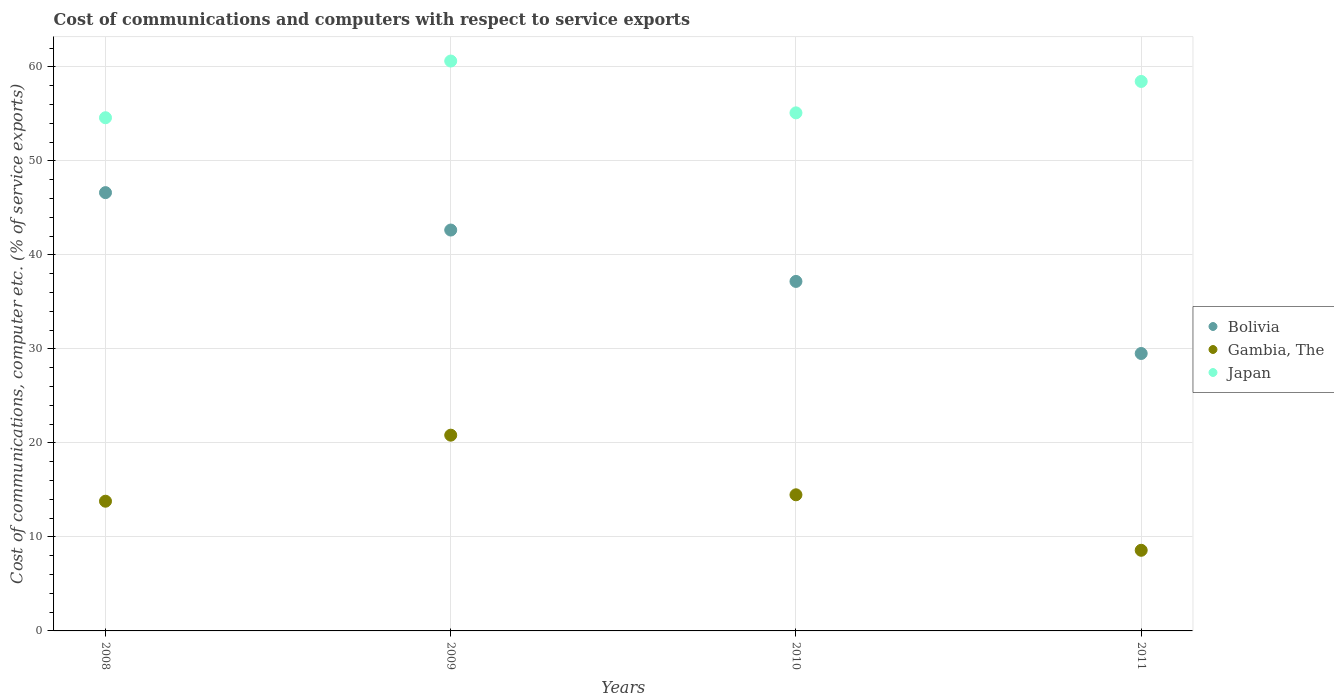How many different coloured dotlines are there?
Make the answer very short. 3. Is the number of dotlines equal to the number of legend labels?
Offer a terse response. Yes. What is the cost of communications and computers in Japan in 2010?
Offer a very short reply. 55.12. Across all years, what is the maximum cost of communications and computers in Japan?
Your answer should be very brief. 60.63. Across all years, what is the minimum cost of communications and computers in Japan?
Offer a very short reply. 54.6. In which year was the cost of communications and computers in Bolivia minimum?
Give a very brief answer. 2011. What is the total cost of communications and computers in Gambia, The in the graph?
Your response must be concise. 57.68. What is the difference between the cost of communications and computers in Gambia, The in 2010 and that in 2011?
Provide a short and direct response. 5.9. What is the difference between the cost of communications and computers in Gambia, The in 2011 and the cost of communications and computers in Bolivia in 2009?
Your response must be concise. -34.07. What is the average cost of communications and computers in Gambia, The per year?
Your answer should be compact. 14.42. In the year 2010, what is the difference between the cost of communications and computers in Japan and cost of communications and computers in Bolivia?
Keep it short and to the point. 17.93. What is the ratio of the cost of communications and computers in Gambia, The in 2009 to that in 2011?
Your answer should be very brief. 2.43. Is the cost of communications and computers in Japan in 2008 less than that in 2009?
Keep it short and to the point. Yes. Is the difference between the cost of communications and computers in Japan in 2008 and 2009 greater than the difference between the cost of communications and computers in Bolivia in 2008 and 2009?
Make the answer very short. No. What is the difference between the highest and the second highest cost of communications and computers in Japan?
Offer a terse response. 2.17. What is the difference between the highest and the lowest cost of communications and computers in Gambia, The?
Your answer should be very brief. 12.25. Is the sum of the cost of communications and computers in Gambia, The in 2009 and 2010 greater than the maximum cost of communications and computers in Bolivia across all years?
Provide a short and direct response. No. Does the graph contain any zero values?
Provide a short and direct response. No. Does the graph contain grids?
Offer a very short reply. Yes. Where does the legend appear in the graph?
Your answer should be compact. Center right. What is the title of the graph?
Keep it short and to the point. Cost of communications and computers with respect to service exports. Does "Upper middle income" appear as one of the legend labels in the graph?
Your answer should be very brief. No. What is the label or title of the X-axis?
Ensure brevity in your answer.  Years. What is the label or title of the Y-axis?
Provide a succinct answer. Cost of communications, computer etc. (% of service exports). What is the Cost of communications, computer etc. (% of service exports) in Bolivia in 2008?
Make the answer very short. 46.63. What is the Cost of communications, computer etc. (% of service exports) in Gambia, The in 2008?
Offer a very short reply. 13.8. What is the Cost of communications, computer etc. (% of service exports) in Japan in 2008?
Give a very brief answer. 54.6. What is the Cost of communications, computer etc. (% of service exports) in Bolivia in 2009?
Offer a very short reply. 42.65. What is the Cost of communications, computer etc. (% of service exports) in Gambia, The in 2009?
Your answer should be very brief. 20.83. What is the Cost of communications, computer etc. (% of service exports) of Japan in 2009?
Offer a very short reply. 60.63. What is the Cost of communications, computer etc. (% of service exports) of Bolivia in 2010?
Make the answer very short. 37.18. What is the Cost of communications, computer etc. (% of service exports) of Gambia, The in 2010?
Your response must be concise. 14.48. What is the Cost of communications, computer etc. (% of service exports) of Japan in 2010?
Make the answer very short. 55.12. What is the Cost of communications, computer etc. (% of service exports) in Bolivia in 2011?
Provide a short and direct response. 29.52. What is the Cost of communications, computer etc. (% of service exports) of Gambia, The in 2011?
Your answer should be very brief. 8.58. What is the Cost of communications, computer etc. (% of service exports) of Japan in 2011?
Ensure brevity in your answer.  58.46. Across all years, what is the maximum Cost of communications, computer etc. (% of service exports) of Bolivia?
Offer a terse response. 46.63. Across all years, what is the maximum Cost of communications, computer etc. (% of service exports) in Gambia, The?
Give a very brief answer. 20.83. Across all years, what is the maximum Cost of communications, computer etc. (% of service exports) of Japan?
Offer a terse response. 60.63. Across all years, what is the minimum Cost of communications, computer etc. (% of service exports) of Bolivia?
Your answer should be compact. 29.52. Across all years, what is the minimum Cost of communications, computer etc. (% of service exports) of Gambia, The?
Your answer should be compact. 8.58. Across all years, what is the minimum Cost of communications, computer etc. (% of service exports) of Japan?
Your response must be concise. 54.6. What is the total Cost of communications, computer etc. (% of service exports) in Bolivia in the graph?
Your response must be concise. 155.98. What is the total Cost of communications, computer etc. (% of service exports) in Gambia, The in the graph?
Make the answer very short. 57.68. What is the total Cost of communications, computer etc. (% of service exports) in Japan in the graph?
Provide a short and direct response. 228.8. What is the difference between the Cost of communications, computer etc. (% of service exports) of Bolivia in 2008 and that in 2009?
Give a very brief answer. 3.98. What is the difference between the Cost of communications, computer etc. (% of service exports) of Gambia, The in 2008 and that in 2009?
Give a very brief answer. -7.03. What is the difference between the Cost of communications, computer etc. (% of service exports) of Japan in 2008 and that in 2009?
Provide a short and direct response. -6.03. What is the difference between the Cost of communications, computer etc. (% of service exports) of Bolivia in 2008 and that in 2010?
Your answer should be compact. 9.45. What is the difference between the Cost of communications, computer etc. (% of service exports) in Gambia, The in 2008 and that in 2010?
Make the answer very short. -0.68. What is the difference between the Cost of communications, computer etc. (% of service exports) in Japan in 2008 and that in 2010?
Ensure brevity in your answer.  -0.52. What is the difference between the Cost of communications, computer etc. (% of service exports) of Bolivia in 2008 and that in 2011?
Your response must be concise. 17.11. What is the difference between the Cost of communications, computer etc. (% of service exports) in Gambia, The in 2008 and that in 2011?
Offer a terse response. 5.22. What is the difference between the Cost of communications, computer etc. (% of service exports) of Japan in 2008 and that in 2011?
Offer a terse response. -3.86. What is the difference between the Cost of communications, computer etc. (% of service exports) in Bolivia in 2009 and that in 2010?
Ensure brevity in your answer.  5.47. What is the difference between the Cost of communications, computer etc. (% of service exports) of Gambia, The in 2009 and that in 2010?
Provide a short and direct response. 6.34. What is the difference between the Cost of communications, computer etc. (% of service exports) of Japan in 2009 and that in 2010?
Your response must be concise. 5.51. What is the difference between the Cost of communications, computer etc. (% of service exports) in Bolivia in 2009 and that in 2011?
Give a very brief answer. 13.13. What is the difference between the Cost of communications, computer etc. (% of service exports) of Gambia, The in 2009 and that in 2011?
Offer a very short reply. 12.25. What is the difference between the Cost of communications, computer etc. (% of service exports) of Japan in 2009 and that in 2011?
Offer a very short reply. 2.17. What is the difference between the Cost of communications, computer etc. (% of service exports) in Bolivia in 2010 and that in 2011?
Your answer should be very brief. 7.67. What is the difference between the Cost of communications, computer etc. (% of service exports) in Gambia, The in 2010 and that in 2011?
Offer a terse response. 5.9. What is the difference between the Cost of communications, computer etc. (% of service exports) in Japan in 2010 and that in 2011?
Your answer should be compact. -3.34. What is the difference between the Cost of communications, computer etc. (% of service exports) in Bolivia in 2008 and the Cost of communications, computer etc. (% of service exports) in Gambia, The in 2009?
Make the answer very short. 25.8. What is the difference between the Cost of communications, computer etc. (% of service exports) of Bolivia in 2008 and the Cost of communications, computer etc. (% of service exports) of Japan in 2009?
Offer a very short reply. -14. What is the difference between the Cost of communications, computer etc. (% of service exports) in Gambia, The in 2008 and the Cost of communications, computer etc. (% of service exports) in Japan in 2009?
Ensure brevity in your answer.  -46.83. What is the difference between the Cost of communications, computer etc. (% of service exports) of Bolivia in 2008 and the Cost of communications, computer etc. (% of service exports) of Gambia, The in 2010?
Keep it short and to the point. 32.15. What is the difference between the Cost of communications, computer etc. (% of service exports) of Bolivia in 2008 and the Cost of communications, computer etc. (% of service exports) of Japan in 2010?
Your answer should be compact. -8.49. What is the difference between the Cost of communications, computer etc. (% of service exports) in Gambia, The in 2008 and the Cost of communications, computer etc. (% of service exports) in Japan in 2010?
Offer a very short reply. -41.32. What is the difference between the Cost of communications, computer etc. (% of service exports) in Bolivia in 2008 and the Cost of communications, computer etc. (% of service exports) in Gambia, The in 2011?
Your response must be concise. 38.05. What is the difference between the Cost of communications, computer etc. (% of service exports) of Bolivia in 2008 and the Cost of communications, computer etc. (% of service exports) of Japan in 2011?
Give a very brief answer. -11.83. What is the difference between the Cost of communications, computer etc. (% of service exports) of Gambia, The in 2008 and the Cost of communications, computer etc. (% of service exports) of Japan in 2011?
Provide a short and direct response. -44.66. What is the difference between the Cost of communications, computer etc. (% of service exports) of Bolivia in 2009 and the Cost of communications, computer etc. (% of service exports) of Gambia, The in 2010?
Make the answer very short. 28.17. What is the difference between the Cost of communications, computer etc. (% of service exports) in Bolivia in 2009 and the Cost of communications, computer etc. (% of service exports) in Japan in 2010?
Your answer should be compact. -12.47. What is the difference between the Cost of communications, computer etc. (% of service exports) of Gambia, The in 2009 and the Cost of communications, computer etc. (% of service exports) of Japan in 2010?
Offer a very short reply. -34.29. What is the difference between the Cost of communications, computer etc. (% of service exports) of Bolivia in 2009 and the Cost of communications, computer etc. (% of service exports) of Gambia, The in 2011?
Make the answer very short. 34.07. What is the difference between the Cost of communications, computer etc. (% of service exports) in Bolivia in 2009 and the Cost of communications, computer etc. (% of service exports) in Japan in 2011?
Make the answer very short. -15.81. What is the difference between the Cost of communications, computer etc. (% of service exports) in Gambia, The in 2009 and the Cost of communications, computer etc. (% of service exports) in Japan in 2011?
Give a very brief answer. -37.63. What is the difference between the Cost of communications, computer etc. (% of service exports) of Bolivia in 2010 and the Cost of communications, computer etc. (% of service exports) of Gambia, The in 2011?
Offer a terse response. 28.61. What is the difference between the Cost of communications, computer etc. (% of service exports) in Bolivia in 2010 and the Cost of communications, computer etc. (% of service exports) in Japan in 2011?
Keep it short and to the point. -21.27. What is the difference between the Cost of communications, computer etc. (% of service exports) in Gambia, The in 2010 and the Cost of communications, computer etc. (% of service exports) in Japan in 2011?
Your answer should be very brief. -43.98. What is the average Cost of communications, computer etc. (% of service exports) of Bolivia per year?
Provide a succinct answer. 38.99. What is the average Cost of communications, computer etc. (% of service exports) of Gambia, The per year?
Give a very brief answer. 14.42. What is the average Cost of communications, computer etc. (% of service exports) in Japan per year?
Your response must be concise. 57.2. In the year 2008, what is the difference between the Cost of communications, computer etc. (% of service exports) of Bolivia and Cost of communications, computer etc. (% of service exports) of Gambia, The?
Keep it short and to the point. 32.83. In the year 2008, what is the difference between the Cost of communications, computer etc. (% of service exports) of Bolivia and Cost of communications, computer etc. (% of service exports) of Japan?
Provide a short and direct response. -7.97. In the year 2008, what is the difference between the Cost of communications, computer etc. (% of service exports) in Gambia, The and Cost of communications, computer etc. (% of service exports) in Japan?
Provide a succinct answer. -40.8. In the year 2009, what is the difference between the Cost of communications, computer etc. (% of service exports) of Bolivia and Cost of communications, computer etc. (% of service exports) of Gambia, The?
Provide a short and direct response. 21.82. In the year 2009, what is the difference between the Cost of communications, computer etc. (% of service exports) in Bolivia and Cost of communications, computer etc. (% of service exports) in Japan?
Keep it short and to the point. -17.98. In the year 2009, what is the difference between the Cost of communications, computer etc. (% of service exports) in Gambia, The and Cost of communications, computer etc. (% of service exports) in Japan?
Provide a succinct answer. -39.8. In the year 2010, what is the difference between the Cost of communications, computer etc. (% of service exports) in Bolivia and Cost of communications, computer etc. (% of service exports) in Gambia, The?
Give a very brief answer. 22.7. In the year 2010, what is the difference between the Cost of communications, computer etc. (% of service exports) in Bolivia and Cost of communications, computer etc. (% of service exports) in Japan?
Give a very brief answer. -17.93. In the year 2010, what is the difference between the Cost of communications, computer etc. (% of service exports) of Gambia, The and Cost of communications, computer etc. (% of service exports) of Japan?
Your answer should be very brief. -40.63. In the year 2011, what is the difference between the Cost of communications, computer etc. (% of service exports) in Bolivia and Cost of communications, computer etc. (% of service exports) in Gambia, The?
Offer a very short reply. 20.94. In the year 2011, what is the difference between the Cost of communications, computer etc. (% of service exports) of Bolivia and Cost of communications, computer etc. (% of service exports) of Japan?
Your response must be concise. -28.94. In the year 2011, what is the difference between the Cost of communications, computer etc. (% of service exports) of Gambia, The and Cost of communications, computer etc. (% of service exports) of Japan?
Give a very brief answer. -49.88. What is the ratio of the Cost of communications, computer etc. (% of service exports) in Bolivia in 2008 to that in 2009?
Ensure brevity in your answer.  1.09. What is the ratio of the Cost of communications, computer etc. (% of service exports) in Gambia, The in 2008 to that in 2009?
Offer a very short reply. 0.66. What is the ratio of the Cost of communications, computer etc. (% of service exports) of Japan in 2008 to that in 2009?
Offer a terse response. 0.9. What is the ratio of the Cost of communications, computer etc. (% of service exports) in Bolivia in 2008 to that in 2010?
Provide a short and direct response. 1.25. What is the ratio of the Cost of communications, computer etc. (% of service exports) of Gambia, The in 2008 to that in 2010?
Give a very brief answer. 0.95. What is the ratio of the Cost of communications, computer etc. (% of service exports) in Japan in 2008 to that in 2010?
Keep it short and to the point. 0.99. What is the ratio of the Cost of communications, computer etc. (% of service exports) in Bolivia in 2008 to that in 2011?
Give a very brief answer. 1.58. What is the ratio of the Cost of communications, computer etc. (% of service exports) in Gambia, The in 2008 to that in 2011?
Offer a terse response. 1.61. What is the ratio of the Cost of communications, computer etc. (% of service exports) of Japan in 2008 to that in 2011?
Offer a very short reply. 0.93. What is the ratio of the Cost of communications, computer etc. (% of service exports) in Bolivia in 2009 to that in 2010?
Make the answer very short. 1.15. What is the ratio of the Cost of communications, computer etc. (% of service exports) of Gambia, The in 2009 to that in 2010?
Your answer should be very brief. 1.44. What is the ratio of the Cost of communications, computer etc. (% of service exports) of Japan in 2009 to that in 2010?
Ensure brevity in your answer.  1.1. What is the ratio of the Cost of communications, computer etc. (% of service exports) of Bolivia in 2009 to that in 2011?
Provide a short and direct response. 1.45. What is the ratio of the Cost of communications, computer etc. (% of service exports) of Gambia, The in 2009 to that in 2011?
Your answer should be compact. 2.43. What is the ratio of the Cost of communications, computer etc. (% of service exports) of Japan in 2009 to that in 2011?
Your answer should be compact. 1.04. What is the ratio of the Cost of communications, computer etc. (% of service exports) in Bolivia in 2010 to that in 2011?
Your response must be concise. 1.26. What is the ratio of the Cost of communications, computer etc. (% of service exports) in Gambia, The in 2010 to that in 2011?
Your answer should be very brief. 1.69. What is the ratio of the Cost of communications, computer etc. (% of service exports) in Japan in 2010 to that in 2011?
Your response must be concise. 0.94. What is the difference between the highest and the second highest Cost of communications, computer etc. (% of service exports) in Bolivia?
Your answer should be compact. 3.98. What is the difference between the highest and the second highest Cost of communications, computer etc. (% of service exports) in Gambia, The?
Provide a succinct answer. 6.34. What is the difference between the highest and the second highest Cost of communications, computer etc. (% of service exports) in Japan?
Provide a succinct answer. 2.17. What is the difference between the highest and the lowest Cost of communications, computer etc. (% of service exports) in Bolivia?
Your response must be concise. 17.11. What is the difference between the highest and the lowest Cost of communications, computer etc. (% of service exports) in Gambia, The?
Offer a terse response. 12.25. What is the difference between the highest and the lowest Cost of communications, computer etc. (% of service exports) in Japan?
Your response must be concise. 6.03. 